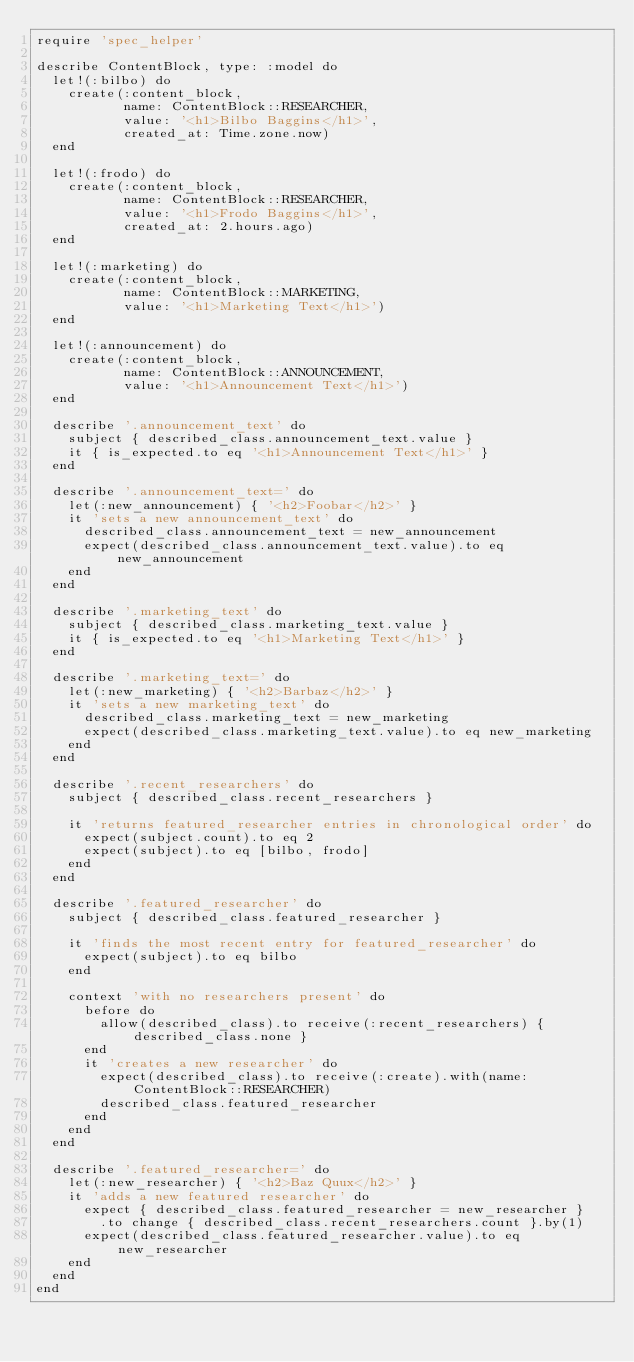Convert code to text. <code><loc_0><loc_0><loc_500><loc_500><_Ruby_>require 'spec_helper'

describe ContentBlock, type: :model do
  let!(:bilbo) do
    create(:content_block,
           name: ContentBlock::RESEARCHER,
           value: '<h1>Bilbo Baggins</h1>',
           created_at: Time.zone.now)
  end

  let!(:frodo) do
    create(:content_block,
           name: ContentBlock::RESEARCHER,
           value: '<h1>Frodo Baggins</h1>',
           created_at: 2.hours.ago)
  end

  let!(:marketing) do
    create(:content_block,
           name: ContentBlock::MARKETING,
           value: '<h1>Marketing Text</h1>')
  end

  let!(:announcement) do
    create(:content_block,
           name: ContentBlock::ANNOUNCEMENT,
           value: '<h1>Announcement Text</h1>')
  end

  describe '.announcement_text' do
    subject { described_class.announcement_text.value }
    it { is_expected.to eq '<h1>Announcement Text</h1>' }
  end

  describe '.announcement_text=' do
    let(:new_announcement) { '<h2>Foobar</h2>' }
    it 'sets a new announcement_text' do
      described_class.announcement_text = new_announcement
      expect(described_class.announcement_text.value).to eq new_announcement
    end
  end

  describe '.marketing_text' do
    subject { described_class.marketing_text.value }
    it { is_expected.to eq '<h1>Marketing Text</h1>' }
  end

  describe '.marketing_text=' do
    let(:new_marketing) { '<h2>Barbaz</h2>' }
    it 'sets a new marketing_text' do
      described_class.marketing_text = new_marketing
      expect(described_class.marketing_text.value).to eq new_marketing
    end
  end

  describe '.recent_researchers' do
    subject { described_class.recent_researchers }

    it 'returns featured_researcher entries in chronological order' do
      expect(subject.count).to eq 2
      expect(subject).to eq [bilbo, frodo]
    end
  end

  describe '.featured_researcher' do
    subject { described_class.featured_researcher }

    it 'finds the most recent entry for featured_researcher' do
      expect(subject).to eq bilbo
    end

    context 'with no researchers present' do
      before do
        allow(described_class).to receive(:recent_researchers) { described_class.none }
      end
      it 'creates a new researcher' do
        expect(described_class).to receive(:create).with(name: ContentBlock::RESEARCHER)
        described_class.featured_researcher
      end
    end
  end

  describe '.featured_researcher=' do
    let(:new_researcher) { '<h2>Baz Quux</h2>' }
    it 'adds a new featured researcher' do
      expect { described_class.featured_researcher = new_researcher }
        .to change { described_class.recent_researchers.count }.by(1)
      expect(described_class.featured_researcher.value).to eq new_researcher
    end
  end
end
</code> 